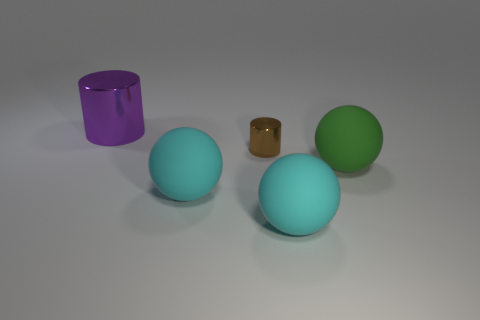What size is the brown shiny cylinder?
Ensure brevity in your answer.  Small. What color is the big thing that is made of the same material as the small object?
Make the answer very short. Purple. Is the number of cyan rubber things that are behind the tiny cylinder less than the number of big purple cylinders?
Provide a short and direct response. Yes. Are there any other things that have the same shape as the big purple thing?
Provide a succinct answer. Yes. Are there fewer brown shiny things than matte objects?
Ensure brevity in your answer.  Yes. There is a cylinder that is in front of the cylinder that is to the left of the brown cylinder; what color is it?
Ensure brevity in your answer.  Brown. What is the material of the thing behind the metallic cylinder that is in front of the metallic cylinder to the left of the brown shiny thing?
Give a very brief answer. Metal. Do the metal thing behind the brown metal cylinder and the green rubber thing have the same size?
Offer a terse response. Yes. There is a big cyan object on the right side of the small brown metallic object; what material is it?
Offer a terse response. Rubber. Is the number of cyan rubber balls greater than the number of rubber things?
Offer a very short reply. No. 